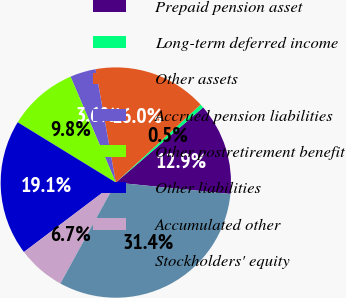Convert chart. <chart><loc_0><loc_0><loc_500><loc_500><pie_chart><fcel>Prepaid pension asset<fcel>Long-term deferred income<fcel>Other assets<fcel>Accrued pension liabilities<fcel>Other postretirement benefit<fcel>Other liabilities<fcel>Accumulated other<fcel>Stockholders' equity<nl><fcel>12.89%<fcel>0.53%<fcel>15.98%<fcel>3.62%<fcel>9.8%<fcel>19.07%<fcel>6.71%<fcel>31.42%<nl></chart> 